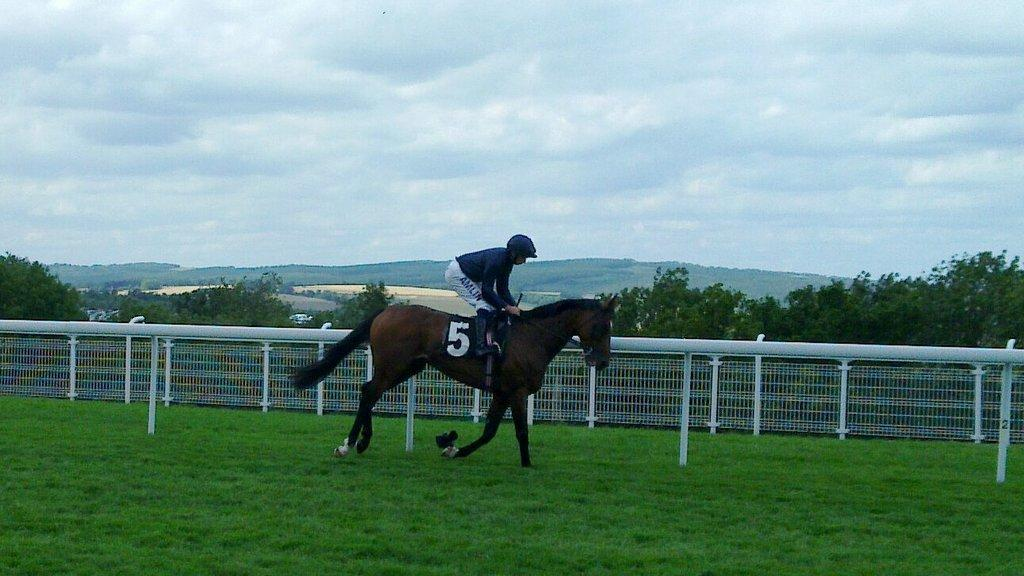What type of terrain is visible in the image? There is grass in the image, which suggests a grassy terrain. What activity is the man in the image engaged in? The man is riding a horse in the image. What type of barrier can be seen in the image? There is a fence in the image. What other natural elements are present in the image? There are trees and hills visible in the image. What is visible in the sky in the image? The sky is visible in the image, and clouds are present. What type of jelly is being used to create the agreement between the man and the horse in the image? There is no jelly present in the image, nor is there any indication of an agreement between the man and the horse. 